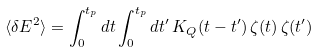Convert formula to latex. <formula><loc_0><loc_0><loc_500><loc_500>\langle \delta E ^ { 2 } \rangle = \int _ { 0 } ^ { t _ { p } } d t \int _ { 0 } ^ { t _ { p } } d t ^ { \prime } \, K _ { Q } ( t - t ^ { \prime } ) \, \zeta ( t ) \, \zeta ( t ^ { \prime } )</formula> 